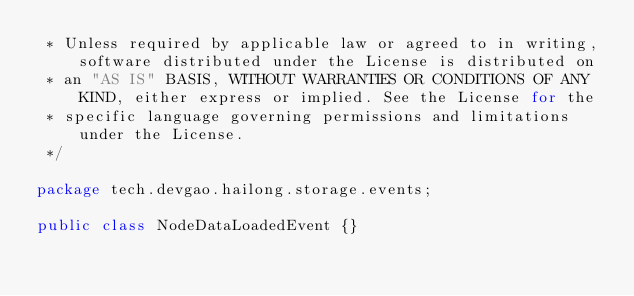<code> <loc_0><loc_0><loc_500><loc_500><_Java_> * Unless required by applicable law or agreed to in writing, software distributed under the License is distributed on
 * an "AS IS" BASIS, WITHOUT WARRANTIES OR CONDITIONS OF ANY KIND, either express or implied. See the License for the
 * specific language governing permissions and limitations under the License.
 */

package tech.devgao.hailong.storage.events;

public class NodeDataLoadedEvent {}
</code> 